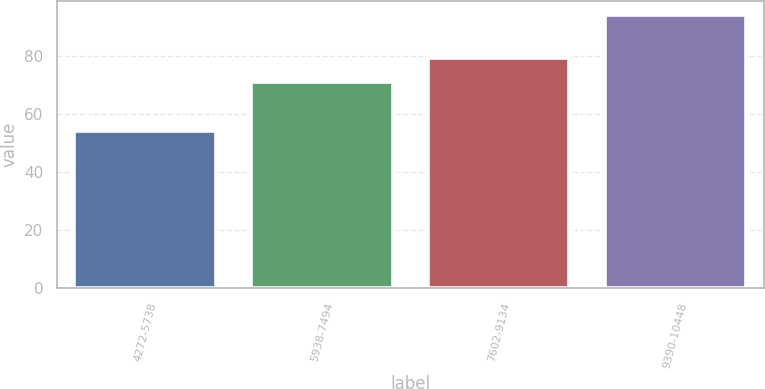Convert chart to OTSL. <chart><loc_0><loc_0><loc_500><loc_500><bar_chart><fcel>4272-5738<fcel>5938-7494<fcel>7602-9134<fcel>9390-10448<nl><fcel>54.21<fcel>70.84<fcel>79.24<fcel>93.97<nl></chart> 